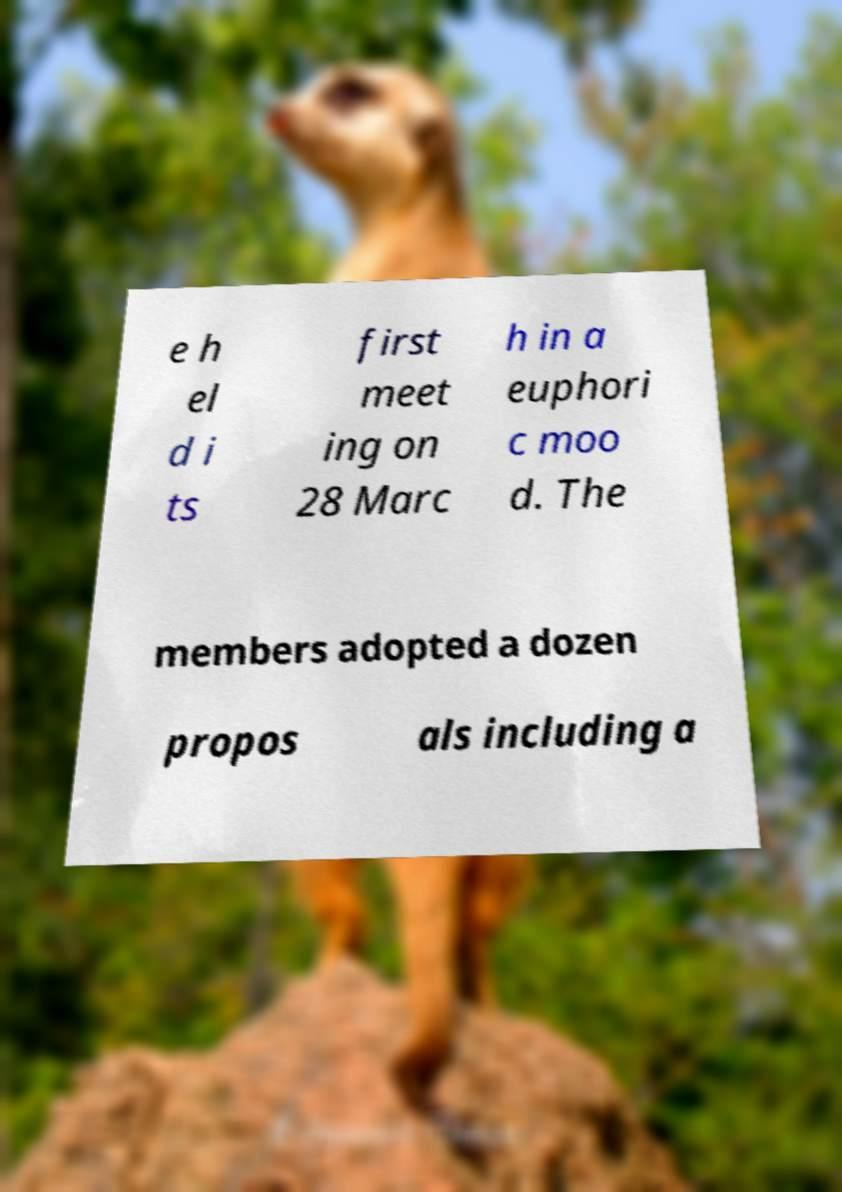Could you assist in decoding the text presented in this image and type it out clearly? e h el d i ts first meet ing on 28 Marc h in a euphori c moo d. The members adopted a dozen propos als including a 